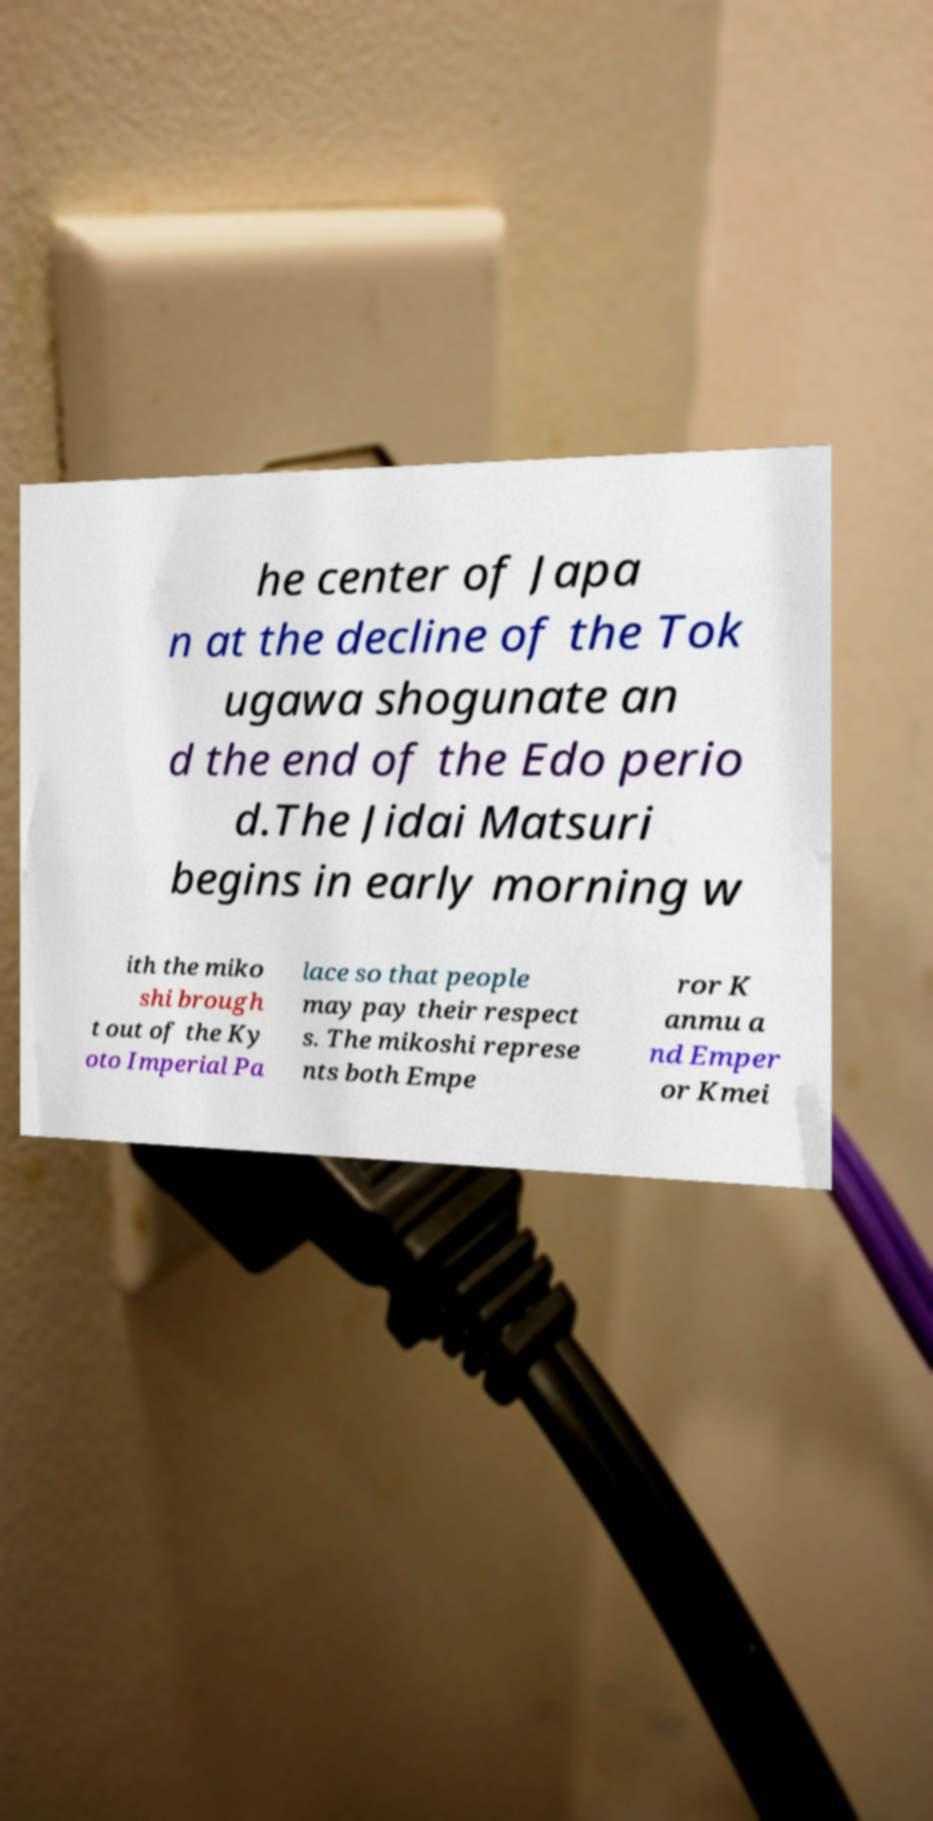Could you extract and type out the text from this image? he center of Japa n at the decline of the Tok ugawa shogunate an d the end of the Edo perio d.The Jidai Matsuri begins in early morning w ith the miko shi brough t out of the Ky oto Imperial Pa lace so that people may pay their respect s. The mikoshi represe nts both Empe ror K anmu a nd Emper or Kmei 